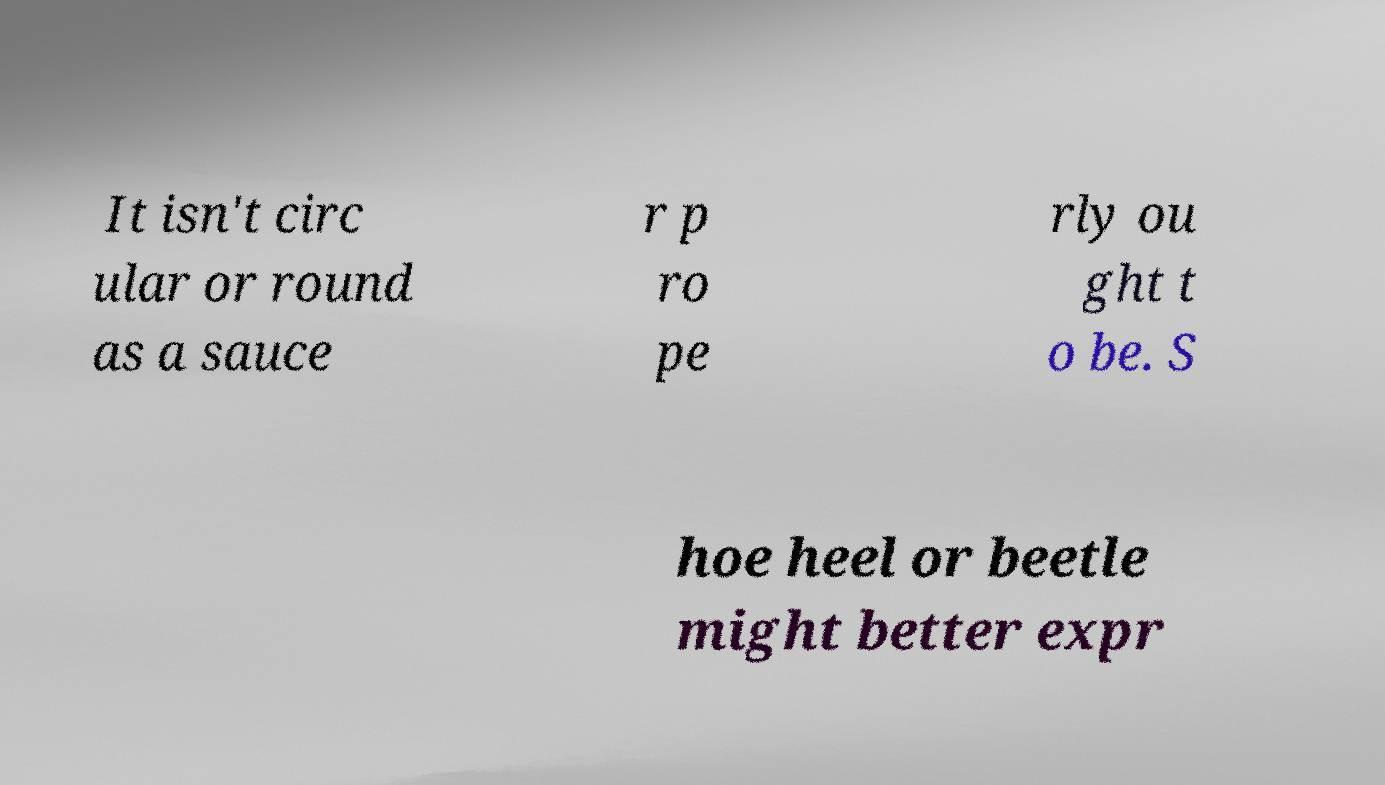Could you assist in decoding the text presented in this image and type it out clearly? It isn't circ ular or round as a sauce r p ro pe rly ou ght t o be. S hoe heel or beetle might better expr 